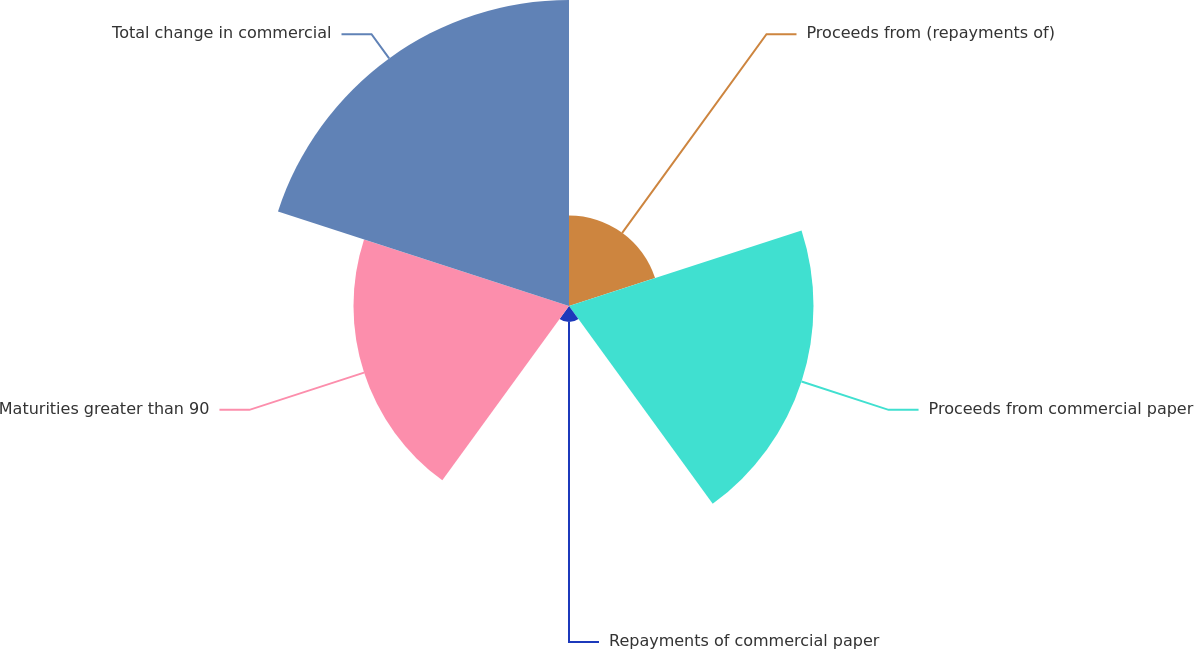Convert chart. <chart><loc_0><loc_0><loc_500><loc_500><pie_chart><fcel>Proceeds from (repayments of)<fcel>Proceeds from commercial paper<fcel>Repayments of commercial paper<fcel>Maturities greater than 90<fcel>Total change in commercial<nl><fcel>10.37%<fcel>28.02%<fcel>1.84%<fcel>24.7%<fcel>35.07%<nl></chart> 